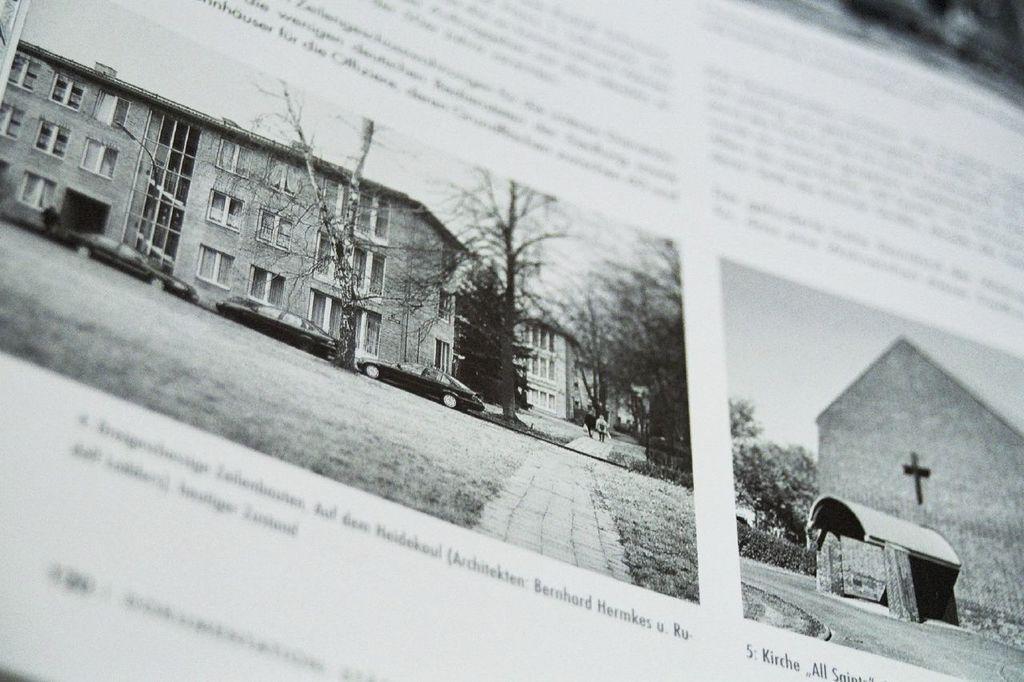Describe this image in one or two sentences. In this picture we can see a paper, there are two pictures and some text on this paper, in this picture we can see buildings, trees, cars and grass, in this picture we can see trees and a wall. 